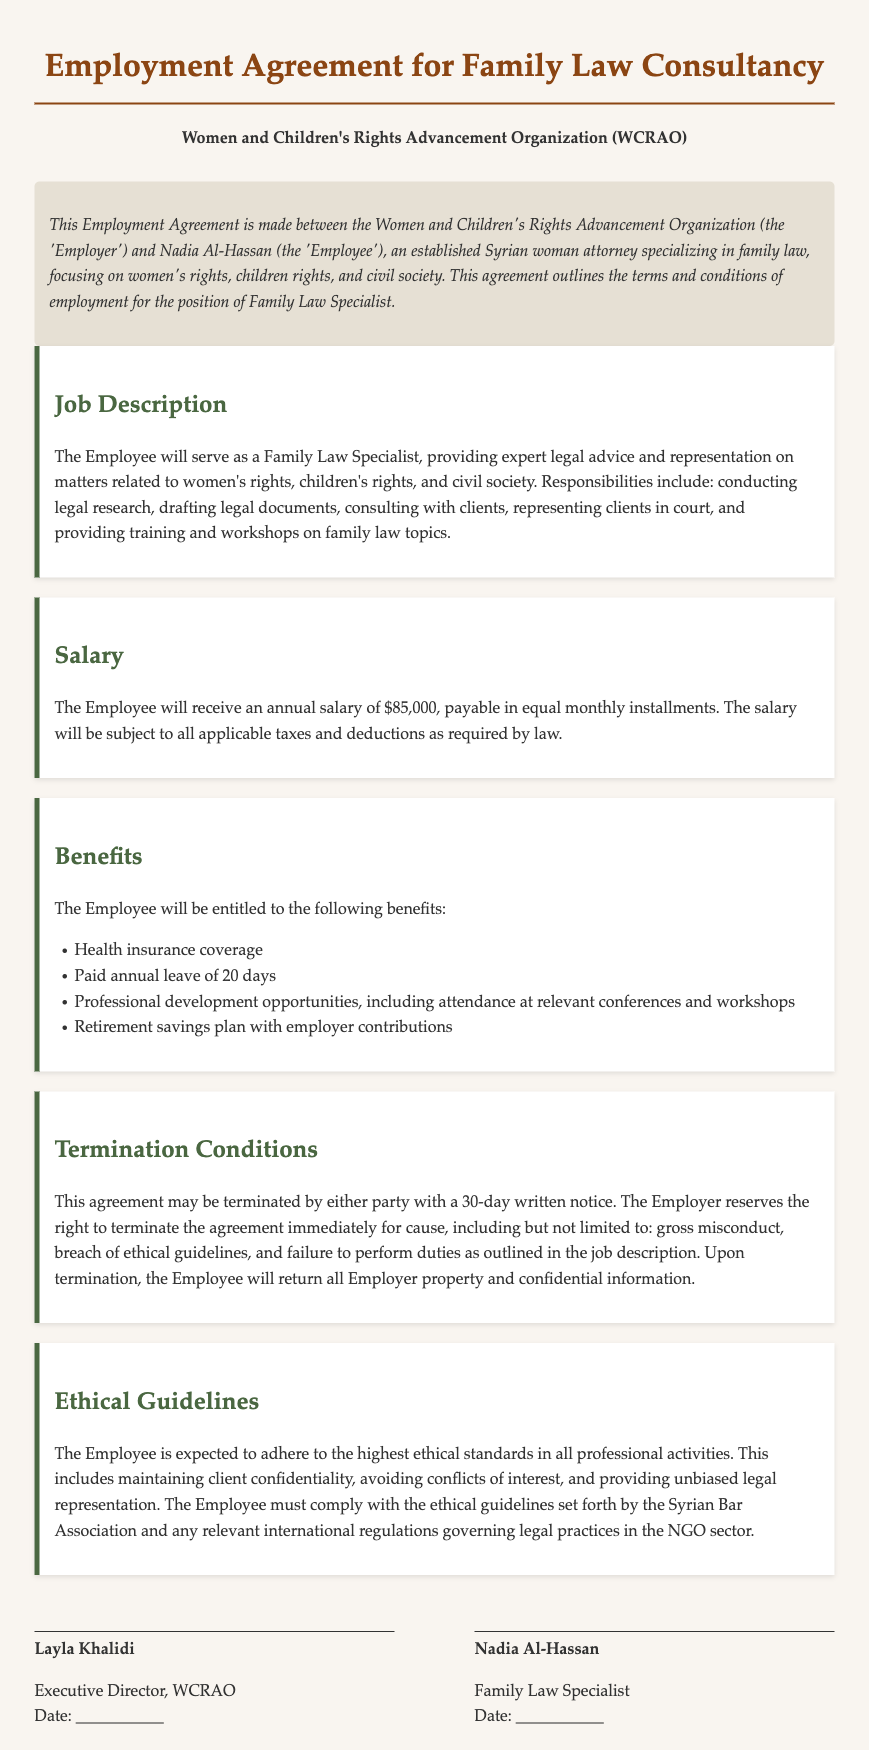What is the position title for the employee? The document explicitly states the position title for the employee, which is "Family Law Specialist."
Answer: Family Law Specialist What is the annual salary mentioned in the agreement? The annual salary is clearly stated in the Salary section as $85,000.
Answer: $85,000 How many days of paid annual leave is the employee entitled to? The Benefits section specifies that the employee is entitled to 20 days of paid annual leave.
Answer: 20 days Under what conditions can the employment agreement be terminated immediately? The Termination Conditions section outlines causes such as gross misconduct and breach of ethical guidelines for immediate termination.
Answer: Gross misconduct, breach of ethical guidelines What does the employee need to return upon termination of the agreement? The document mentions that the employee must return all Employer property and confidential information upon termination.
Answer: Employer property and confidential information Which organization is the employer in the contract? The employer is clearly identified at the beginning of the document as "Women and Children's Rights Advancement Organization (WCRAO)."
Answer: Women and Children's Rights Advancement Organization (WCRAO) What ethical standards must the employee adhere to? Ethical guidelines section states the requirement to maintain client confidentiality and avoid conflicts of interest among others.
Answer: Maintain client confidentiality and avoid conflicts of interest What type of insurance coverage is offered as a benefit? The document specifies that the employee will have health insurance coverage as part of the benefits.
Answer: Health insurance coverage What is the written notice period for terminating the agreement? The agreement specifies a 30-day written notice for termination by either party.
Answer: 30 days 